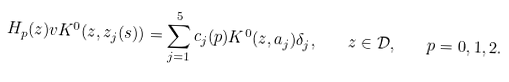<formula> <loc_0><loc_0><loc_500><loc_500>H _ { p } ( z ) v K ^ { 0 } ( z , z _ { j } ( s ) ) = \sum _ { j = 1 } ^ { 5 } c _ { j } ( p ) K ^ { 0 } ( z , a _ { j } ) \delta _ { j } , \quad z \in \mathcal { D } , \quad p = 0 , 1 , 2 .</formula> 